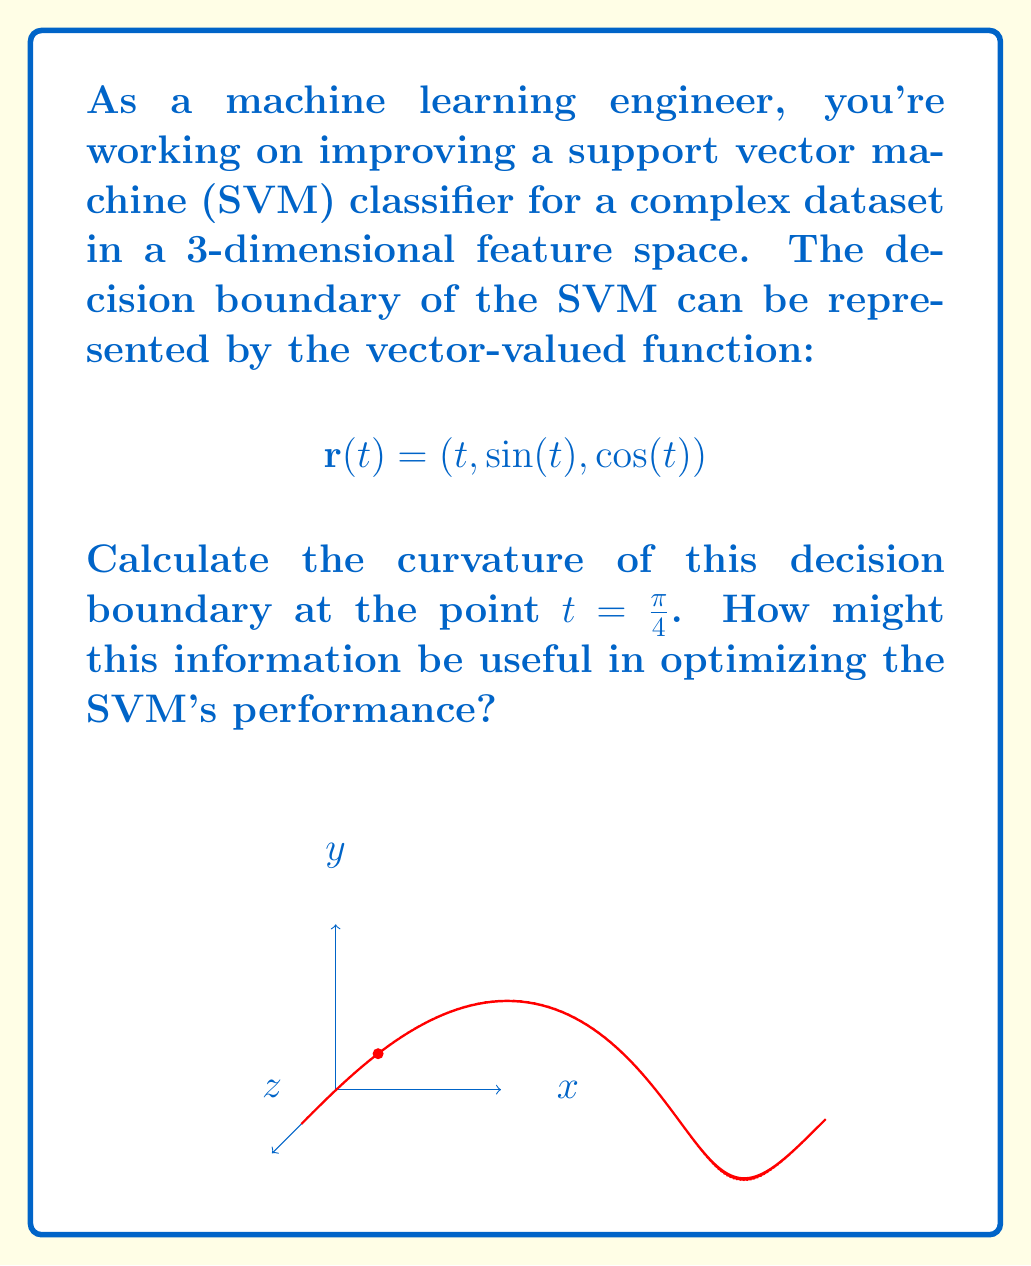Could you help me with this problem? To calculate the curvature of the decision boundary, we'll follow these steps:

1) The curvature κ is given by the formula:

   $$\kappa = \frac{|\mathbf{r}'(t) \times \mathbf{r}''(t)|}{|\mathbf{r}'(t)|^3}$$

2) First, let's calculate $\mathbf{r}'(t)$:
   $$\mathbf{r}'(t) = (1, \cos(t), -\sin(t))$$

3) Then, calculate $\mathbf{r}''(t)$:
   $$\mathbf{r}''(t) = (0, -\sin(t), -\cos(t))$$

4) Now, we need to evaluate these at $t = \frac{\pi}{4}$:
   $$\mathbf{r}'(\frac{\pi}{4}) = (1, \frac{\sqrt{2}}{2}, -\frac{\sqrt{2}}{2})$$
   $$\mathbf{r}''(\frac{\pi}{4}) = (0, -\frac{\sqrt{2}}{2}, -\frac{\sqrt{2}}{2})$$

5) Calculate the cross product $\mathbf{r}'(\frac{\pi}{4}) \times \mathbf{r}''(\frac{\pi}{4})$:
   $$\mathbf{r}'(\frac{\pi}{4}) \times \mathbf{r}''(\frac{\pi}{4}) = (\frac{1}{2}, \frac{\sqrt{2}}{2}, -\frac{\sqrt{2}}{2})$$

6) Calculate the magnitude of this cross product:
   $$|\mathbf{r}'(\frac{\pi}{4}) \times \mathbf{r}''(\frac{\pi}{4})| = \sqrt{(\frac{1}{2})^2 + (\frac{\sqrt{2}}{2})^2 + (-\frac{\sqrt{2}}{2})^2} = 1$$

7) Calculate $|\mathbf{r}'(\frac{\pi}{4})|^3$:
   $$|\mathbf{r}'(\frac{\pi}{4})|^3 = (1^2 + (\frac{\sqrt{2}}{2})^2 + (-\frac{\sqrt{2}}{2})^2)^{3/2} = 2^{3/2} = 2\sqrt{2}$$

8) Finally, calculate the curvature:
   $$\kappa = \frac{1}{2\sqrt{2}} = \frac{\sqrt{2}}{4}$$

This curvature information can be useful in optimizing the SVM's performance by:
1) Helping to choose appropriate kernel functions
2) Guiding the selection of regularization parameters
3) Informing feature engineering decisions to potentially simplify the decision boundary
Answer: $\frac{\sqrt{2}}{4}$ 